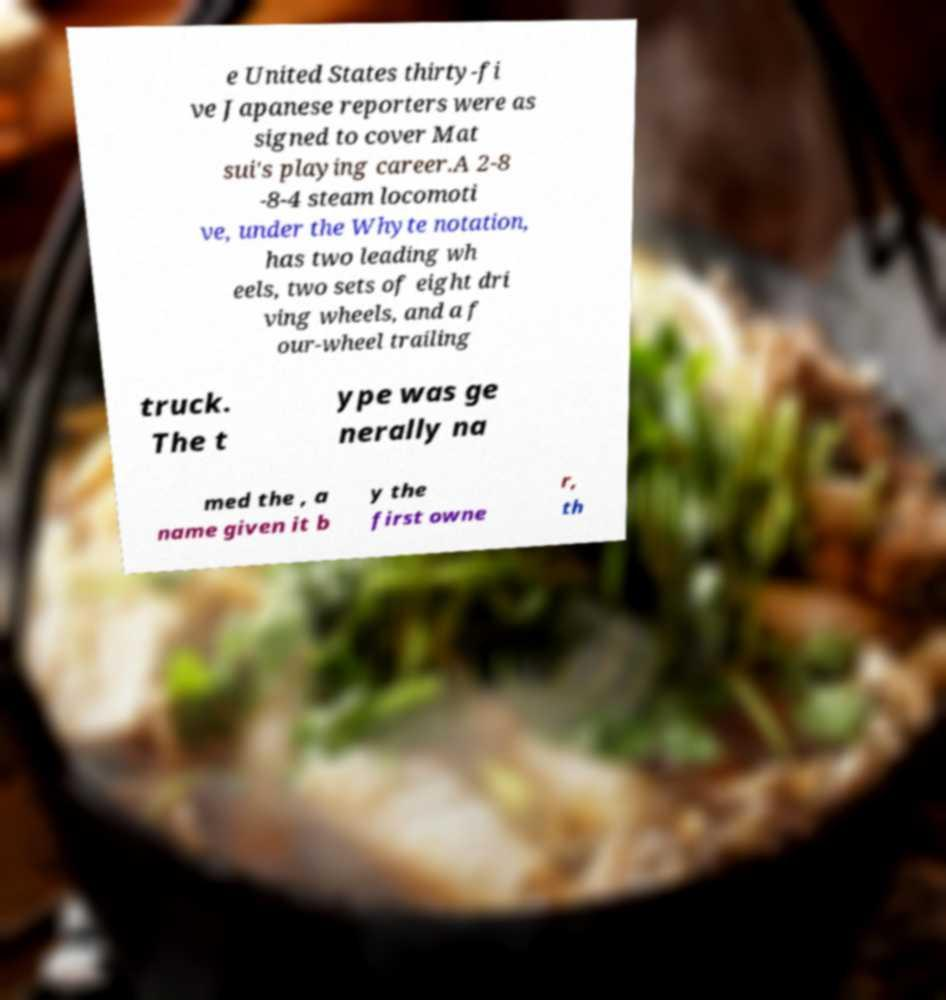Please identify and transcribe the text found in this image. e United States thirty-fi ve Japanese reporters were as signed to cover Mat sui's playing career.A 2-8 -8-4 steam locomoti ve, under the Whyte notation, has two leading wh eels, two sets of eight dri ving wheels, and a f our-wheel trailing truck. The t ype was ge nerally na med the , a name given it b y the first owne r, th 